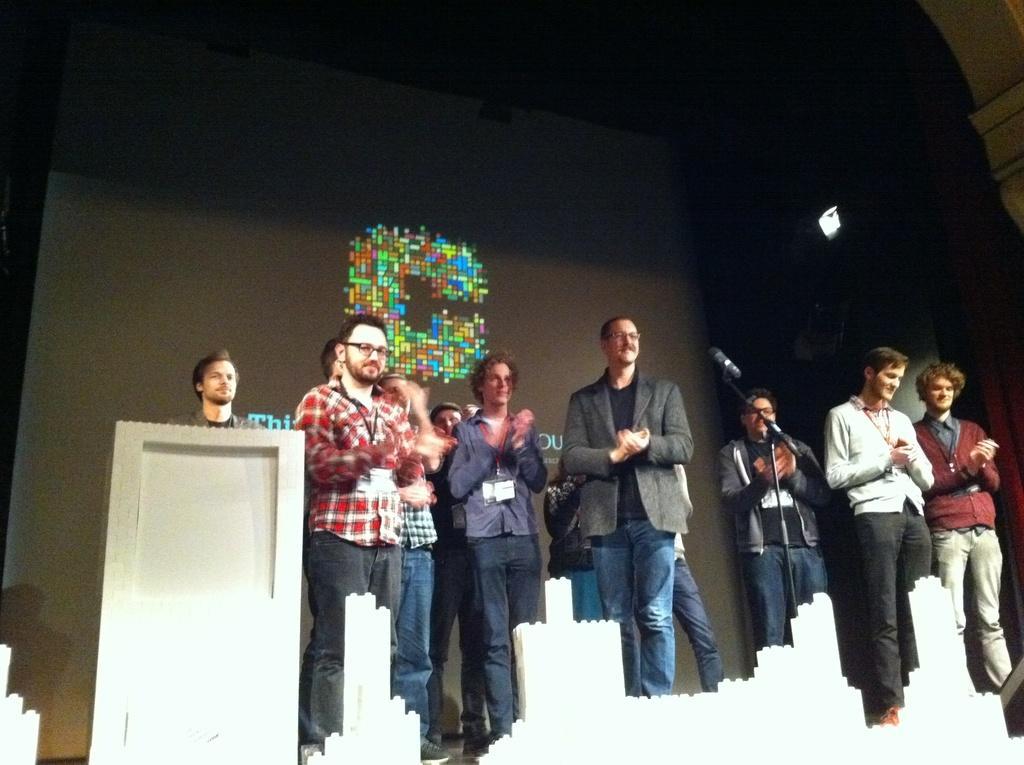In one or two sentences, can you explain what this image depicts? In this image there are people standing on the stage. There is a dais. There is a mike. In the background of the image there is a screen. On the right side of the image there is a light. 